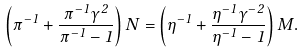Convert formula to latex. <formula><loc_0><loc_0><loc_500><loc_500>\left ( \pi ^ { - 1 } + \frac { \pi ^ { - 1 } \gamma ^ { 2 } } { \pi ^ { - 1 } - 1 } \right ) N = \left ( \eta ^ { - 1 } + \frac { \eta ^ { - 1 } \gamma ^ { - 2 } } { \eta ^ { - 1 } - 1 } \right ) M .</formula> 